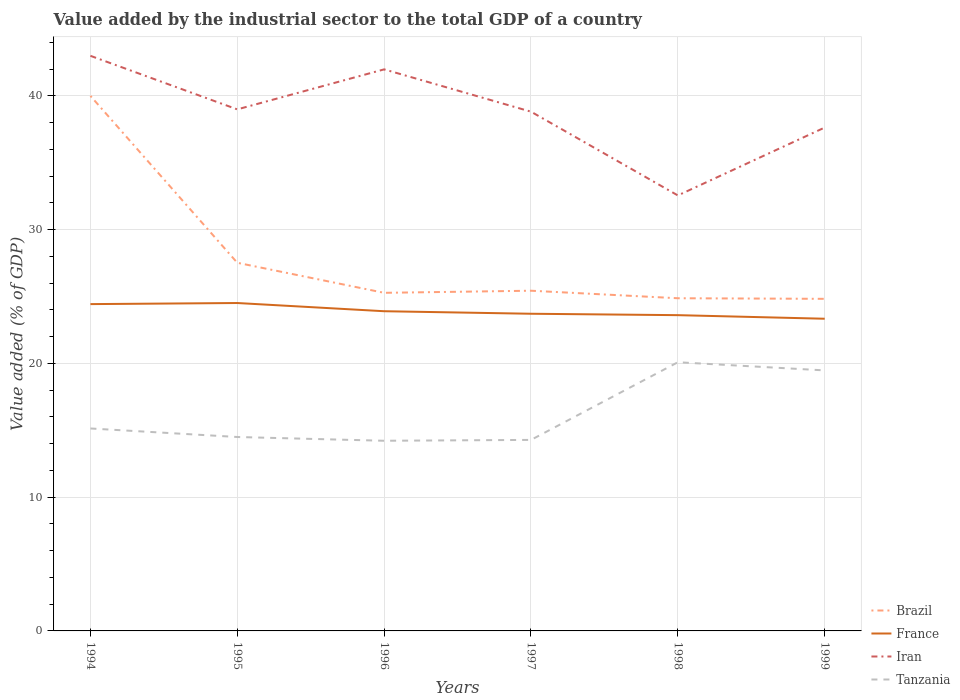How many different coloured lines are there?
Ensure brevity in your answer.  4. Is the number of lines equal to the number of legend labels?
Offer a terse response. Yes. Across all years, what is the maximum value added by the industrial sector to the total GDP in Iran?
Give a very brief answer. 32.56. In which year was the value added by the industrial sector to the total GDP in Tanzania maximum?
Provide a succinct answer. 1996. What is the total value added by the industrial sector to the total GDP in France in the graph?
Your answer should be very brief. 1.09. What is the difference between the highest and the second highest value added by the industrial sector to the total GDP in Tanzania?
Your response must be concise. 5.87. How many lines are there?
Your answer should be very brief. 4. How many years are there in the graph?
Offer a very short reply. 6. Are the values on the major ticks of Y-axis written in scientific E-notation?
Ensure brevity in your answer.  No. Does the graph contain any zero values?
Your response must be concise. No. Does the graph contain grids?
Your answer should be very brief. Yes. Where does the legend appear in the graph?
Give a very brief answer. Bottom right. How many legend labels are there?
Offer a very short reply. 4. What is the title of the graph?
Offer a very short reply. Value added by the industrial sector to the total GDP of a country. What is the label or title of the X-axis?
Keep it short and to the point. Years. What is the label or title of the Y-axis?
Offer a terse response. Value added (% of GDP). What is the Value added (% of GDP) of Brazil in 1994?
Your answer should be compact. 40. What is the Value added (% of GDP) in France in 1994?
Make the answer very short. 24.43. What is the Value added (% of GDP) of Iran in 1994?
Provide a short and direct response. 43. What is the Value added (% of GDP) in Tanzania in 1994?
Your response must be concise. 15.14. What is the Value added (% of GDP) of Brazil in 1995?
Provide a succinct answer. 27.53. What is the Value added (% of GDP) of France in 1995?
Your response must be concise. 24.52. What is the Value added (% of GDP) in Iran in 1995?
Provide a succinct answer. 38.99. What is the Value added (% of GDP) in Tanzania in 1995?
Keep it short and to the point. 14.5. What is the Value added (% of GDP) in Brazil in 1996?
Provide a short and direct response. 25.28. What is the Value added (% of GDP) in France in 1996?
Your answer should be compact. 23.9. What is the Value added (% of GDP) in Iran in 1996?
Your response must be concise. 41.99. What is the Value added (% of GDP) of Tanzania in 1996?
Ensure brevity in your answer.  14.22. What is the Value added (% of GDP) of Brazil in 1997?
Your answer should be very brief. 25.44. What is the Value added (% of GDP) in France in 1997?
Make the answer very short. 23.71. What is the Value added (% of GDP) in Iran in 1997?
Your answer should be very brief. 38.82. What is the Value added (% of GDP) of Tanzania in 1997?
Your answer should be very brief. 14.28. What is the Value added (% of GDP) in Brazil in 1998?
Your answer should be compact. 24.87. What is the Value added (% of GDP) of France in 1998?
Keep it short and to the point. 23.61. What is the Value added (% of GDP) of Iran in 1998?
Make the answer very short. 32.56. What is the Value added (% of GDP) of Tanzania in 1998?
Your response must be concise. 20.09. What is the Value added (% of GDP) in Brazil in 1999?
Give a very brief answer. 24.83. What is the Value added (% of GDP) in France in 1999?
Your response must be concise. 23.34. What is the Value added (% of GDP) of Iran in 1999?
Make the answer very short. 37.64. What is the Value added (% of GDP) in Tanzania in 1999?
Provide a succinct answer. 19.48. Across all years, what is the maximum Value added (% of GDP) of Brazil?
Provide a short and direct response. 40. Across all years, what is the maximum Value added (% of GDP) in France?
Offer a very short reply. 24.52. Across all years, what is the maximum Value added (% of GDP) of Iran?
Keep it short and to the point. 43. Across all years, what is the maximum Value added (% of GDP) of Tanzania?
Make the answer very short. 20.09. Across all years, what is the minimum Value added (% of GDP) of Brazil?
Offer a terse response. 24.83. Across all years, what is the minimum Value added (% of GDP) of France?
Keep it short and to the point. 23.34. Across all years, what is the minimum Value added (% of GDP) in Iran?
Your response must be concise. 32.56. Across all years, what is the minimum Value added (% of GDP) of Tanzania?
Your answer should be compact. 14.22. What is the total Value added (% of GDP) in Brazil in the graph?
Your answer should be compact. 167.95. What is the total Value added (% of GDP) in France in the graph?
Your answer should be very brief. 143.52. What is the total Value added (% of GDP) of Iran in the graph?
Offer a terse response. 233. What is the total Value added (% of GDP) in Tanzania in the graph?
Keep it short and to the point. 97.7. What is the difference between the Value added (% of GDP) of Brazil in 1994 and that in 1995?
Give a very brief answer. 12.48. What is the difference between the Value added (% of GDP) in France in 1994 and that in 1995?
Give a very brief answer. -0.08. What is the difference between the Value added (% of GDP) of Iran in 1994 and that in 1995?
Provide a succinct answer. 4. What is the difference between the Value added (% of GDP) of Tanzania in 1994 and that in 1995?
Offer a very short reply. 0.64. What is the difference between the Value added (% of GDP) of Brazil in 1994 and that in 1996?
Offer a very short reply. 14.72. What is the difference between the Value added (% of GDP) in France in 1994 and that in 1996?
Provide a succinct answer. 0.53. What is the difference between the Value added (% of GDP) in Tanzania in 1994 and that in 1996?
Provide a succinct answer. 0.92. What is the difference between the Value added (% of GDP) in Brazil in 1994 and that in 1997?
Your answer should be compact. 14.57. What is the difference between the Value added (% of GDP) of France in 1994 and that in 1997?
Provide a succinct answer. 0.72. What is the difference between the Value added (% of GDP) in Iran in 1994 and that in 1997?
Ensure brevity in your answer.  4.18. What is the difference between the Value added (% of GDP) in Tanzania in 1994 and that in 1997?
Offer a terse response. 0.85. What is the difference between the Value added (% of GDP) in Brazil in 1994 and that in 1998?
Offer a very short reply. 15.13. What is the difference between the Value added (% of GDP) in France in 1994 and that in 1998?
Provide a short and direct response. 0.83. What is the difference between the Value added (% of GDP) of Iran in 1994 and that in 1998?
Give a very brief answer. 10.44. What is the difference between the Value added (% of GDP) of Tanzania in 1994 and that in 1998?
Keep it short and to the point. -4.95. What is the difference between the Value added (% of GDP) in Brazil in 1994 and that in 1999?
Give a very brief answer. 15.17. What is the difference between the Value added (% of GDP) in France in 1994 and that in 1999?
Offer a terse response. 1.09. What is the difference between the Value added (% of GDP) of Iran in 1994 and that in 1999?
Make the answer very short. 5.36. What is the difference between the Value added (% of GDP) of Tanzania in 1994 and that in 1999?
Provide a short and direct response. -4.34. What is the difference between the Value added (% of GDP) in Brazil in 1995 and that in 1996?
Your response must be concise. 2.25. What is the difference between the Value added (% of GDP) in France in 1995 and that in 1996?
Your response must be concise. 0.61. What is the difference between the Value added (% of GDP) in Iran in 1995 and that in 1996?
Offer a very short reply. -2.99. What is the difference between the Value added (% of GDP) in Tanzania in 1995 and that in 1996?
Offer a terse response. 0.28. What is the difference between the Value added (% of GDP) in Brazil in 1995 and that in 1997?
Offer a terse response. 2.09. What is the difference between the Value added (% of GDP) of France in 1995 and that in 1997?
Offer a terse response. 0.8. What is the difference between the Value added (% of GDP) in Iran in 1995 and that in 1997?
Your answer should be very brief. 0.17. What is the difference between the Value added (% of GDP) in Tanzania in 1995 and that in 1997?
Your response must be concise. 0.22. What is the difference between the Value added (% of GDP) of Brazil in 1995 and that in 1998?
Ensure brevity in your answer.  2.65. What is the difference between the Value added (% of GDP) of France in 1995 and that in 1998?
Your answer should be very brief. 0.91. What is the difference between the Value added (% of GDP) in Iran in 1995 and that in 1998?
Your response must be concise. 6.43. What is the difference between the Value added (% of GDP) of Tanzania in 1995 and that in 1998?
Offer a very short reply. -5.59. What is the difference between the Value added (% of GDP) in Brazil in 1995 and that in 1999?
Offer a very short reply. 2.7. What is the difference between the Value added (% of GDP) in France in 1995 and that in 1999?
Give a very brief answer. 1.17. What is the difference between the Value added (% of GDP) of Iran in 1995 and that in 1999?
Make the answer very short. 1.36. What is the difference between the Value added (% of GDP) of Tanzania in 1995 and that in 1999?
Offer a very short reply. -4.98. What is the difference between the Value added (% of GDP) in Brazil in 1996 and that in 1997?
Provide a short and direct response. -0.16. What is the difference between the Value added (% of GDP) in France in 1996 and that in 1997?
Offer a terse response. 0.19. What is the difference between the Value added (% of GDP) of Iran in 1996 and that in 1997?
Keep it short and to the point. 3.16. What is the difference between the Value added (% of GDP) of Tanzania in 1996 and that in 1997?
Your answer should be very brief. -0.06. What is the difference between the Value added (% of GDP) in Brazil in 1996 and that in 1998?
Ensure brevity in your answer.  0.41. What is the difference between the Value added (% of GDP) of France in 1996 and that in 1998?
Your answer should be compact. 0.29. What is the difference between the Value added (% of GDP) in Iran in 1996 and that in 1998?
Ensure brevity in your answer.  9.43. What is the difference between the Value added (% of GDP) in Tanzania in 1996 and that in 1998?
Your response must be concise. -5.87. What is the difference between the Value added (% of GDP) in Brazil in 1996 and that in 1999?
Give a very brief answer. 0.45. What is the difference between the Value added (% of GDP) of France in 1996 and that in 1999?
Give a very brief answer. 0.56. What is the difference between the Value added (% of GDP) of Iran in 1996 and that in 1999?
Provide a short and direct response. 4.35. What is the difference between the Value added (% of GDP) in Tanzania in 1996 and that in 1999?
Give a very brief answer. -5.26. What is the difference between the Value added (% of GDP) of Brazil in 1997 and that in 1998?
Offer a terse response. 0.56. What is the difference between the Value added (% of GDP) of France in 1997 and that in 1998?
Offer a terse response. 0.11. What is the difference between the Value added (% of GDP) of Iran in 1997 and that in 1998?
Give a very brief answer. 6.26. What is the difference between the Value added (% of GDP) of Tanzania in 1997 and that in 1998?
Ensure brevity in your answer.  -5.81. What is the difference between the Value added (% of GDP) in Brazil in 1997 and that in 1999?
Keep it short and to the point. 0.61. What is the difference between the Value added (% of GDP) of France in 1997 and that in 1999?
Offer a terse response. 0.37. What is the difference between the Value added (% of GDP) in Iran in 1997 and that in 1999?
Give a very brief answer. 1.19. What is the difference between the Value added (% of GDP) of Tanzania in 1997 and that in 1999?
Your response must be concise. -5.2. What is the difference between the Value added (% of GDP) of Brazil in 1998 and that in 1999?
Provide a succinct answer. 0.04. What is the difference between the Value added (% of GDP) in France in 1998 and that in 1999?
Your response must be concise. 0.27. What is the difference between the Value added (% of GDP) of Iran in 1998 and that in 1999?
Make the answer very short. -5.08. What is the difference between the Value added (% of GDP) of Tanzania in 1998 and that in 1999?
Offer a very short reply. 0.61. What is the difference between the Value added (% of GDP) in Brazil in 1994 and the Value added (% of GDP) in France in 1995?
Your answer should be compact. 15.49. What is the difference between the Value added (% of GDP) in Brazil in 1994 and the Value added (% of GDP) in Iran in 1995?
Make the answer very short. 1.01. What is the difference between the Value added (% of GDP) of Brazil in 1994 and the Value added (% of GDP) of Tanzania in 1995?
Offer a terse response. 25.5. What is the difference between the Value added (% of GDP) in France in 1994 and the Value added (% of GDP) in Iran in 1995?
Ensure brevity in your answer.  -14.56. What is the difference between the Value added (% of GDP) of France in 1994 and the Value added (% of GDP) of Tanzania in 1995?
Ensure brevity in your answer.  9.94. What is the difference between the Value added (% of GDP) of Iran in 1994 and the Value added (% of GDP) of Tanzania in 1995?
Make the answer very short. 28.5. What is the difference between the Value added (% of GDP) in Brazil in 1994 and the Value added (% of GDP) in France in 1996?
Give a very brief answer. 16.1. What is the difference between the Value added (% of GDP) of Brazil in 1994 and the Value added (% of GDP) of Iran in 1996?
Keep it short and to the point. -1.98. What is the difference between the Value added (% of GDP) in Brazil in 1994 and the Value added (% of GDP) in Tanzania in 1996?
Give a very brief answer. 25.78. What is the difference between the Value added (% of GDP) of France in 1994 and the Value added (% of GDP) of Iran in 1996?
Provide a succinct answer. -17.55. What is the difference between the Value added (% of GDP) in France in 1994 and the Value added (% of GDP) in Tanzania in 1996?
Your answer should be very brief. 10.22. What is the difference between the Value added (% of GDP) of Iran in 1994 and the Value added (% of GDP) of Tanzania in 1996?
Make the answer very short. 28.78. What is the difference between the Value added (% of GDP) in Brazil in 1994 and the Value added (% of GDP) in France in 1997?
Your answer should be very brief. 16.29. What is the difference between the Value added (% of GDP) of Brazil in 1994 and the Value added (% of GDP) of Iran in 1997?
Provide a succinct answer. 1.18. What is the difference between the Value added (% of GDP) in Brazil in 1994 and the Value added (% of GDP) in Tanzania in 1997?
Your answer should be very brief. 25.72. What is the difference between the Value added (% of GDP) of France in 1994 and the Value added (% of GDP) of Iran in 1997?
Give a very brief answer. -14.39. What is the difference between the Value added (% of GDP) of France in 1994 and the Value added (% of GDP) of Tanzania in 1997?
Your answer should be very brief. 10.15. What is the difference between the Value added (% of GDP) in Iran in 1994 and the Value added (% of GDP) in Tanzania in 1997?
Make the answer very short. 28.72. What is the difference between the Value added (% of GDP) of Brazil in 1994 and the Value added (% of GDP) of France in 1998?
Make the answer very short. 16.39. What is the difference between the Value added (% of GDP) of Brazil in 1994 and the Value added (% of GDP) of Iran in 1998?
Give a very brief answer. 7.44. What is the difference between the Value added (% of GDP) of Brazil in 1994 and the Value added (% of GDP) of Tanzania in 1998?
Keep it short and to the point. 19.91. What is the difference between the Value added (% of GDP) of France in 1994 and the Value added (% of GDP) of Iran in 1998?
Provide a short and direct response. -8.13. What is the difference between the Value added (% of GDP) in France in 1994 and the Value added (% of GDP) in Tanzania in 1998?
Ensure brevity in your answer.  4.35. What is the difference between the Value added (% of GDP) of Iran in 1994 and the Value added (% of GDP) of Tanzania in 1998?
Your response must be concise. 22.91. What is the difference between the Value added (% of GDP) in Brazil in 1994 and the Value added (% of GDP) in France in 1999?
Offer a terse response. 16.66. What is the difference between the Value added (% of GDP) in Brazil in 1994 and the Value added (% of GDP) in Iran in 1999?
Provide a succinct answer. 2.37. What is the difference between the Value added (% of GDP) of Brazil in 1994 and the Value added (% of GDP) of Tanzania in 1999?
Your answer should be compact. 20.52. What is the difference between the Value added (% of GDP) in France in 1994 and the Value added (% of GDP) in Iran in 1999?
Provide a succinct answer. -13.2. What is the difference between the Value added (% of GDP) of France in 1994 and the Value added (% of GDP) of Tanzania in 1999?
Your response must be concise. 4.96. What is the difference between the Value added (% of GDP) of Iran in 1994 and the Value added (% of GDP) of Tanzania in 1999?
Your answer should be compact. 23.52. What is the difference between the Value added (% of GDP) of Brazil in 1995 and the Value added (% of GDP) of France in 1996?
Make the answer very short. 3.62. What is the difference between the Value added (% of GDP) of Brazil in 1995 and the Value added (% of GDP) of Iran in 1996?
Your answer should be very brief. -14.46. What is the difference between the Value added (% of GDP) of Brazil in 1995 and the Value added (% of GDP) of Tanzania in 1996?
Give a very brief answer. 13.31. What is the difference between the Value added (% of GDP) in France in 1995 and the Value added (% of GDP) in Iran in 1996?
Give a very brief answer. -17.47. What is the difference between the Value added (% of GDP) in France in 1995 and the Value added (% of GDP) in Tanzania in 1996?
Keep it short and to the point. 10.3. What is the difference between the Value added (% of GDP) in Iran in 1995 and the Value added (% of GDP) in Tanzania in 1996?
Provide a short and direct response. 24.78. What is the difference between the Value added (% of GDP) in Brazil in 1995 and the Value added (% of GDP) in France in 1997?
Provide a short and direct response. 3.81. What is the difference between the Value added (% of GDP) of Brazil in 1995 and the Value added (% of GDP) of Iran in 1997?
Keep it short and to the point. -11.3. What is the difference between the Value added (% of GDP) in Brazil in 1995 and the Value added (% of GDP) in Tanzania in 1997?
Keep it short and to the point. 13.24. What is the difference between the Value added (% of GDP) of France in 1995 and the Value added (% of GDP) of Iran in 1997?
Offer a terse response. -14.31. What is the difference between the Value added (% of GDP) of France in 1995 and the Value added (% of GDP) of Tanzania in 1997?
Give a very brief answer. 10.23. What is the difference between the Value added (% of GDP) in Iran in 1995 and the Value added (% of GDP) in Tanzania in 1997?
Your response must be concise. 24.71. What is the difference between the Value added (% of GDP) of Brazil in 1995 and the Value added (% of GDP) of France in 1998?
Provide a short and direct response. 3.92. What is the difference between the Value added (% of GDP) in Brazil in 1995 and the Value added (% of GDP) in Iran in 1998?
Provide a succinct answer. -5.03. What is the difference between the Value added (% of GDP) in Brazil in 1995 and the Value added (% of GDP) in Tanzania in 1998?
Make the answer very short. 7.44. What is the difference between the Value added (% of GDP) in France in 1995 and the Value added (% of GDP) in Iran in 1998?
Keep it short and to the point. -8.04. What is the difference between the Value added (% of GDP) of France in 1995 and the Value added (% of GDP) of Tanzania in 1998?
Your response must be concise. 4.43. What is the difference between the Value added (% of GDP) in Iran in 1995 and the Value added (% of GDP) in Tanzania in 1998?
Ensure brevity in your answer.  18.91. What is the difference between the Value added (% of GDP) in Brazil in 1995 and the Value added (% of GDP) in France in 1999?
Keep it short and to the point. 4.18. What is the difference between the Value added (% of GDP) in Brazil in 1995 and the Value added (% of GDP) in Iran in 1999?
Offer a terse response. -10.11. What is the difference between the Value added (% of GDP) in Brazil in 1995 and the Value added (% of GDP) in Tanzania in 1999?
Give a very brief answer. 8.05. What is the difference between the Value added (% of GDP) in France in 1995 and the Value added (% of GDP) in Iran in 1999?
Provide a short and direct response. -13.12. What is the difference between the Value added (% of GDP) of France in 1995 and the Value added (% of GDP) of Tanzania in 1999?
Your answer should be very brief. 5.04. What is the difference between the Value added (% of GDP) in Iran in 1995 and the Value added (% of GDP) in Tanzania in 1999?
Give a very brief answer. 19.52. What is the difference between the Value added (% of GDP) of Brazil in 1996 and the Value added (% of GDP) of France in 1997?
Offer a very short reply. 1.56. What is the difference between the Value added (% of GDP) of Brazil in 1996 and the Value added (% of GDP) of Iran in 1997?
Provide a succinct answer. -13.54. What is the difference between the Value added (% of GDP) in Brazil in 1996 and the Value added (% of GDP) in Tanzania in 1997?
Make the answer very short. 11. What is the difference between the Value added (% of GDP) of France in 1996 and the Value added (% of GDP) of Iran in 1997?
Your answer should be very brief. -14.92. What is the difference between the Value added (% of GDP) in France in 1996 and the Value added (% of GDP) in Tanzania in 1997?
Your response must be concise. 9.62. What is the difference between the Value added (% of GDP) of Iran in 1996 and the Value added (% of GDP) of Tanzania in 1997?
Provide a succinct answer. 27.7. What is the difference between the Value added (% of GDP) of Brazil in 1996 and the Value added (% of GDP) of France in 1998?
Your response must be concise. 1.67. What is the difference between the Value added (% of GDP) in Brazil in 1996 and the Value added (% of GDP) in Iran in 1998?
Your answer should be compact. -7.28. What is the difference between the Value added (% of GDP) in Brazil in 1996 and the Value added (% of GDP) in Tanzania in 1998?
Your answer should be compact. 5.19. What is the difference between the Value added (% of GDP) in France in 1996 and the Value added (% of GDP) in Iran in 1998?
Offer a very short reply. -8.66. What is the difference between the Value added (% of GDP) of France in 1996 and the Value added (% of GDP) of Tanzania in 1998?
Your answer should be compact. 3.81. What is the difference between the Value added (% of GDP) of Iran in 1996 and the Value added (% of GDP) of Tanzania in 1998?
Provide a short and direct response. 21.9. What is the difference between the Value added (% of GDP) in Brazil in 1996 and the Value added (% of GDP) in France in 1999?
Your response must be concise. 1.94. What is the difference between the Value added (% of GDP) of Brazil in 1996 and the Value added (% of GDP) of Iran in 1999?
Ensure brevity in your answer.  -12.36. What is the difference between the Value added (% of GDP) in Brazil in 1996 and the Value added (% of GDP) in Tanzania in 1999?
Provide a succinct answer. 5.8. What is the difference between the Value added (% of GDP) of France in 1996 and the Value added (% of GDP) of Iran in 1999?
Keep it short and to the point. -13.73. What is the difference between the Value added (% of GDP) of France in 1996 and the Value added (% of GDP) of Tanzania in 1999?
Your response must be concise. 4.42. What is the difference between the Value added (% of GDP) of Iran in 1996 and the Value added (% of GDP) of Tanzania in 1999?
Ensure brevity in your answer.  22.51. What is the difference between the Value added (% of GDP) in Brazil in 1997 and the Value added (% of GDP) in France in 1998?
Your answer should be compact. 1.83. What is the difference between the Value added (% of GDP) of Brazil in 1997 and the Value added (% of GDP) of Iran in 1998?
Your answer should be compact. -7.12. What is the difference between the Value added (% of GDP) of Brazil in 1997 and the Value added (% of GDP) of Tanzania in 1998?
Offer a very short reply. 5.35. What is the difference between the Value added (% of GDP) of France in 1997 and the Value added (% of GDP) of Iran in 1998?
Ensure brevity in your answer.  -8.85. What is the difference between the Value added (% of GDP) of France in 1997 and the Value added (% of GDP) of Tanzania in 1998?
Keep it short and to the point. 3.63. What is the difference between the Value added (% of GDP) of Iran in 1997 and the Value added (% of GDP) of Tanzania in 1998?
Your response must be concise. 18.73. What is the difference between the Value added (% of GDP) in Brazil in 1997 and the Value added (% of GDP) in France in 1999?
Your answer should be very brief. 2.09. What is the difference between the Value added (% of GDP) of Brazil in 1997 and the Value added (% of GDP) of Iran in 1999?
Your answer should be very brief. -12.2. What is the difference between the Value added (% of GDP) in Brazil in 1997 and the Value added (% of GDP) in Tanzania in 1999?
Your answer should be very brief. 5.96. What is the difference between the Value added (% of GDP) of France in 1997 and the Value added (% of GDP) of Iran in 1999?
Keep it short and to the point. -13.92. What is the difference between the Value added (% of GDP) of France in 1997 and the Value added (% of GDP) of Tanzania in 1999?
Ensure brevity in your answer.  4.24. What is the difference between the Value added (% of GDP) of Iran in 1997 and the Value added (% of GDP) of Tanzania in 1999?
Your answer should be compact. 19.34. What is the difference between the Value added (% of GDP) of Brazil in 1998 and the Value added (% of GDP) of France in 1999?
Offer a very short reply. 1.53. What is the difference between the Value added (% of GDP) in Brazil in 1998 and the Value added (% of GDP) in Iran in 1999?
Keep it short and to the point. -12.76. What is the difference between the Value added (% of GDP) in Brazil in 1998 and the Value added (% of GDP) in Tanzania in 1999?
Provide a succinct answer. 5.4. What is the difference between the Value added (% of GDP) in France in 1998 and the Value added (% of GDP) in Iran in 1999?
Make the answer very short. -14.03. What is the difference between the Value added (% of GDP) in France in 1998 and the Value added (% of GDP) in Tanzania in 1999?
Offer a very short reply. 4.13. What is the difference between the Value added (% of GDP) of Iran in 1998 and the Value added (% of GDP) of Tanzania in 1999?
Give a very brief answer. 13.08. What is the average Value added (% of GDP) of Brazil per year?
Make the answer very short. 27.99. What is the average Value added (% of GDP) in France per year?
Offer a very short reply. 23.92. What is the average Value added (% of GDP) of Iran per year?
Provide a succinct answer. 38.83. What is the average Value added (% of GDP) in Tanzania per year?
Provide a succinct answer. 16.28. In the year 1994, what is the difference between the Value added (% of GDP) of Brazil and Value added (% of GDP) of France?
Your answer should be very brief. 15.57. In the year 1994, what is the difference between the Value added (% of GDP) of Brazil and Value added (% of GDP) of Iran?
Your response must be concise. -3. In the year 1994, what is the difference between the Value added (% of GDP) in Brazil and Value added (% of GDP) in Tanzania?
Offer a very short reply. 24.87. In the year 1994, what is the difference between the Value added (% of GDP) in France and Value added (% of GDP) in Iran?
Keep it short and to the point. -18.56. In the year 1994, what is the difference between the Value added (% of GDP) in France and Value added (% of GDP) in Tanzania?
Offer a terse response. 9.3. In the year 1994, what is the difference between the Value added (% of GDP) in Iran and Value added (% of GDP) in Tanzania?
Make the answer very short. 27.86. In the year 1995, what is the difference between the Value added (% of GDP) of Brazil and Value added (% of GDP) of France?
Offer a very short reply. 3.01. In the year 1995, what is the difference between the Value added (% of GDP) in Brazil and Value added (% of GDP) in Iran?
Offer a very short reply. -11.47. In the year 1995, what is the difference between the Value added (% of GDP) of Brazil and Value added (% of GDP) of Tanzania?
Offer a very short reply. 13.03. In the year 1995, what is the difference between the Value added (% of GDP) of France and Value added (% of GDP) of Iran?
Ensure brevity in your answer.  -14.48. In the year 1995, what is the difference between the Value added (% of GDP) of France and Value added (% of GDP) of Tanzania?
Ensure brevity in your answer.  10.02. In the year 1995, what is the difference between the Value added (% of GDP) in Iran and Value added (% of GDP) in Tanzania?
Offer a very short reply. 24.5. In the year 1996, what is the difference between the Value added (% of GDP) of Brazil and Value added (% of GDP) of France?
Your response must be concise. 1.38. In the year 1996, what is the difference between the Value added (% of GDP) in Brazil and Value added (% of GDP) in Iran?
Keep it short and to the point. -16.71. In the year 1996, what is the difference between the Value added (% of GDP) in Brazil and Value added (% of GDP) in Tanzania?
Offer a terse response. 11.06. In the year 1996, what is the difference between the Value added (% of GDP) of France and Value added (% of GDP) of Iran?
Provide a succinct answer. -18.08. In the year 1996, what is the difference between the Value added (% of GDP) in France and Value added (% of GDP) in Tanzania?
Ensure brevity in your answer.  9.68. In the year 1996, what is the difference between the Value added (% of GDP) of Iran and Value added (% of GDP) of Tanzania?
Your answer should be very brief. 27.77. In the year 1997, what is the difference between the Value added (% of GDP) of Brazil and Value added (% of GDP) of France?
Your response must be concise. 1.72. In the year 1997, what is the difference between the Value added (% of GDP) in Brazil and Value added (% of GDP) in Iran?
Give a very brief answer. -13.39. In the year 1997, what is the difference between the Value added (% of GDP) in Brazil and Value added (% of GDP) in Tanzania?
Offer a terse response. 11.15. In the year 1997, what is the difference between the Value added (% of GDP) of France and Value added (% of GDP) of Iran?
Your answer should be compact. -15.11. In the year 1997, what is the difference between the Value added (% of GDP) of France and Value added (% of GDP) of Tanzania?
Your answer should be very brief. 9.43. In the year 1997, what is the difference between the Value added (% of GDP) in Iran and Value added (% of GDP) in Tanzania?
Offer a terse response. 24.54. In the year 1998, what is the difference between the Value added (% of GDP) of Brazil and Value added (% of GDP) of France?
Your response must be concise. 1.26. In the year 1998, what is the difference between the Value added (% of GDP) in Brazil and Value added (% of GDP) in Iran?
Provide a short and direct response. -7.69. In the year 1998, what is the difference between the Value added (% of GDP) in Brazil and Value added (% of GDP) in Tanzania?
Give a very brief answer. 4.79. In the year 1998, what is the difference between the Value added (% of GDP) of France and Value added (% of GDP) of Iran?
Ensure brevity in your answer.  -8.95. In the year 1998, what is the difference between the Value added (% of GDP) of France and Value added (% of GDP) of Tanzania?
Your answer should be very brief. 3.52. In the year 1998, what is the difference between the Value added (% of GDP) in Iran and Value added (% of GDP) in Tanzania?
Provide a short and direct response. 12.47. In the year 1999, what is the difference between the Value added (% of GDP) in Brazil and Value added (% of GDP) in France?
Offer a terse response. 1.49. In the year 1999, what is the difference between the Value added (% of GDP) of Brazil and Value added (% of GDP) of Iran?
Offer a very short reply. -12.81. In the year 1999, what is the difference between the Value added (% of GDP) in Brazil and Value added (% of GDP) in Tanzania?
Your answer should be very brief. 5.35. In the year 1999, what is the difference between the Value added (% of GDP) of France and Value added (% of GDP) of Iran?
Your response must be concise. -14.29. In the year 1999, what is the difference between the Value added (% of GDP) of France and Value added (% of GDP) of Tanzania?
Provide a succinct answer. 3.86. In the year 1999, what is the difference between the Value added (% of GDP) of Iran and Value added (% of GDP) of Tanzania?
Offer a terse response. 18.16. What is the ratio of the Value added (% of GDP) of Brazil in 1994 to that in 1995?
Provide a short and direct response. 1.45. What is the ratio of the Value added (% of GDP) in Iran in 1994 to that in 1995?
Your answer should be very brief. 1.1. What is the ratio of the Value added (% of GDP) in Tanzania in 1994 to that in 1995?
Provide a succinct answer. 1.04. What is the ratio of the Value added (% of GDP) of Brazil in 1994 to that in 1996?
Keep it short and to the point. 1.58. What is the ratio of the Value added (% of GDP) of France in 1994 to that in 1996?
Ensure brevity in your answer.  1.02. What is the ratio of the Value added (% of GDP) of Iran in 1994 to that in 1996?
Offer a very short reply. 1.02. What is the ratio of the Value added (% of GDP) in Tanzania in 1994 to that in 1996?
Provide a succinct answer. 1.06. What is the ratio of the Value added (% of GDP) in Brazil in 1994 to that in 1997?
Offer a very short reply. 1.57. What is the ratio of the Value added (% of GDP) of France in 1994 to that in 1997?
Ensure brevity in your answer.  1.03. What is the ratio of the Value added (% of GDP) in Iran in 1994 to that in 1997?
Provide a succinct answer. 1.11. What is the ratio of the Value added (% of GDP) of Tanzania in 1994 to that in 1997?
Ensure brevity in your answer.  1.06. What is the ratio of the Value added (% of GDP) of Brazil in 1994 to that in 1998?
Offer a terse response. 1.61. What is the ratio of the Value added (% of GDP) of France in 1994 to that in 1998?
Your answer should be very brief. 1.03. What is the ratio of the Value added (% of GDP) in Iran in 1994 to that in 1998?
Offer a terse response. 1.32. What is the ratio of the Value added (% of GDP) in Tanzania in 1994 to that in 1998?
Your answer should be very brief. 0.75. What is the ratio of the Value added (% of GDP) in Brazil in 1994 to that in 1999?
Make the answer very short. 1.61. What is the ratio of the Value added (% of GDP) in France in 1994 to that in 1999?
Your answer should be very brief. 1.05. What is the ratio of the Value added (% of GDP) in Iran in 1994 to that in 1999?
Keep it short and to the point. 1.14. What is the ratio of the Value added (% of GDP) in Tanzania in 1994 to that in 1999?
Provide a short and direct response. 0.78. What is the ratio of the Value added (% of GDP) in Brazil in 1995 to that in 1996?
Make the answer very short. 1.09. What is the ratio of the Value added (% of GDP) in France in 1995 to that in 1996?
Keep it short and to the point. 1.03. What is the ratio of the Value added (% of GDP) in Iran in 1995 to that in 1996?
Your answer should be compact. 0.93. What is the ratio of the Value added (% of GDP) in Tanzania in 1995 to that in 1996?
Offer a terse response. 1.02. What is the ratio of the Value added (% of GDP) of Brazil in 1995 to that in 1997?
Make the answer very short. 1.08. What is the ratio of the Value added (% of GDP) of France in 1995 to that in 1997?
Make the answer very short. 1.03. What is the ratio of the Value added (% of GDP) of Iran in 1995 to that in 1997?
Your response must be concise. 1. What is the ratio of the Value added (% of GDP) in Tanzania in 1995 to that in 1997?
Keep it short and to the point. 1.02. What is the ratio of the Value added (% of GDP) of Brazil in 1995 to that in 1998?
Ensure brevity in your answer.  1.11. What is the ratio of the Value added (% of GDP) of Iran in 1995 to that in 1998?
Provide a succinct answer. 1.2. What is the ratio of the Value added (% of GDP) of Tanzania in 1995 to that in 1998?
Offer a terse response. 0.72. What is the ratio of the Value added (% of GDP) in Brazil in 1995 to that in 1999?
Provide a succinct answer. 1.11. What is the ratio of the Value added (% of GDP) in France in 1995 to that in 1999?
Keep it short and to the point. 1.05. What is the ratio of the Value added (% of GDP) in Iran in 1995 to that in 1999?
Offer a very short reply. 1.04. What is the ratio of the Value added (% of GDP) in Tanzania in 1995 to that in 1999?
Give a very brief answer. 0.74. What is the ratio of the Value added (% of GDP) of France in 1996 to that in 1997?
Provide a succinct answer. 1.01. What is the ratio of the Value added (% of GDP) of Iran in 1996 to that in 1997?
Keep it short and to the point. 1.08. What is the ratio of the Value added (% of GDP) in Tanzania in 1996 to that in 1997?
Your response must be concise. 1. What is the ratio of the Value added (% of GDP) in Brazil in 1996 to that in 1998?
Make the answer very short. 1.02. What is the ratio of the Value added (% of GDP) of France in 1996 to that in 1998?
Keep it short and to the point. 1.01. What is the ratio of the Value added (% of GDP) of Iran in 1996 to that in 1998?
Provide a succinct answer. 1.29. What is the ratio of the Value added (% of GDP) of Tanzania in 1996 to that in 1998?
Your response must be concise. 0.71. What is the ratio of the Value added (% of GDP) of Brazil in 1996 to that in 1999?
Your response must be concise. 1.02. What is the ratio of the Value added (% of GDP) of Iran in 1996 to that in 1999?
Your response must be concise. 1.12. What is the ratio of the Value added (% of GDP) in Tanzania in 1996 to that in 1999?
Give a very brief answer. 0.73. What is the ratio of the Value added (% of GDP) in Brazil in 1997 to that in 1998?
Provide a short and direct response. 1.02. What is the ratio of the Value added (% of GDP) of France in 1997 to that in 1998?
Your response must be concise. 1. What is the ratio of the Value added (% of GDP) in Iran in 1997 to that in 1998?
Offer a terse response. 1.19. What is the ratio of the Value added (% of GDP) in Tanzania in 1997 to that in 1998?
Offer a very short reply. 0.71. What is the ratio of the Value added (% of GDP) of Brazil in 1997 to that in 1999?
Offer a very short reply. 1.02. What is the ratio of the Value added (% of GDP) of France in 1997 to that in 1999?
Make the answer very short. 1.02. What is the ratio of the Value added (% of GDP) of Iran in 1997 to that in 1999?
Your answer should be very brief. 1.03. What is the ratio of the Value added (% of GDP) of Tanzania in 1997 to that in 1999?
Provide a short and direct response. 0.73. What is the ratio of the Value added (% of GDP) of Brazil in 1998 to that in 1999?
Provide a short and direct response. 1. What is the ratio of the Value added (% of GDP) of France in 1998 to that in 1999?
Your answer should be very brief. 1.01. What is the ratio of the Value added (% of GDP) of Iran in 1998 to that in 1999?
Your answer should be very brief. 0.87. What is the ratio of the Value added (% of GDP) of Tanzania in 1998 to that in 1999?
Your answer should be very brief. 1.03. What is the difference between the highest and the second highest Value added (% of GDP) in Brazil?
Your answer should be compact. 12.48. What is the difference between the highest and the second highest Value added (% of GDP) in France?
Your answer should be compact. 0.08. What is the difference between the highest and the second highest Value added (% of GDP) of Tanzania?
Provide a short and direct response. 0.61. What is the difference between the highest and the lowest Value added (% of GDP) of Brazil?
Ensure brevity in your answer.  15.17. What is the difference between the highest and the lowest Value added (% of GDP) of France?
Make the answer very short. 1.17. What is the difference between the highest and the lowest Value added (% of GDP) of Iran?
Ensure brevity in your answer.  10.44. What is the difference between the highest and the lowest Value added (% of GDP) of Tanzania?
Offer a very short reply. 5.87. 